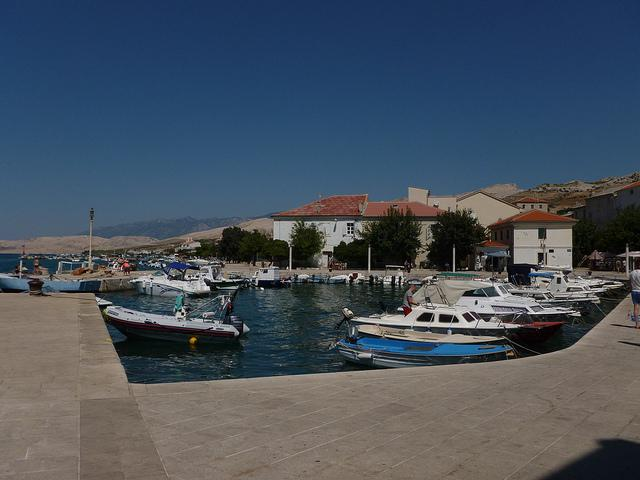What color is the top of the speed boat that is closest to the corner of the dock? white 